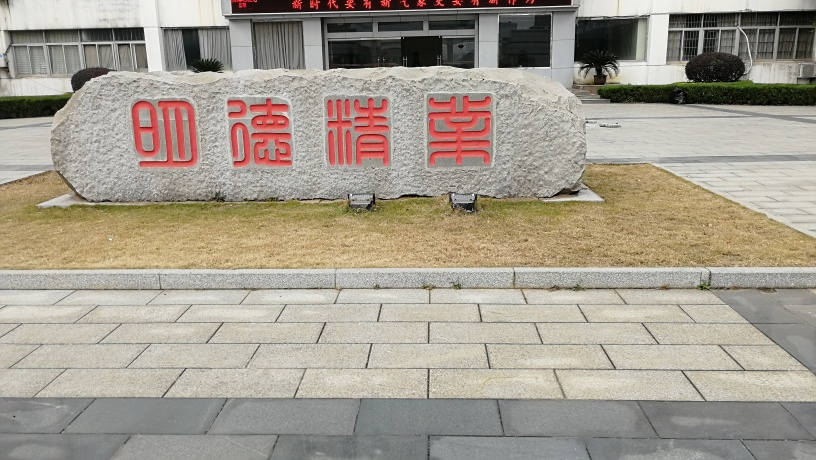What can you infer about the location this photo was taken? The image seems to be taken in a formal or institutional setting, as suggested by the well-maintained pavement and the neatly trimmed grass. The presence of the inscribed boulder hints at a place of significance, possibly a park, a university, or government grounds in a region where Chinese characters are used. 